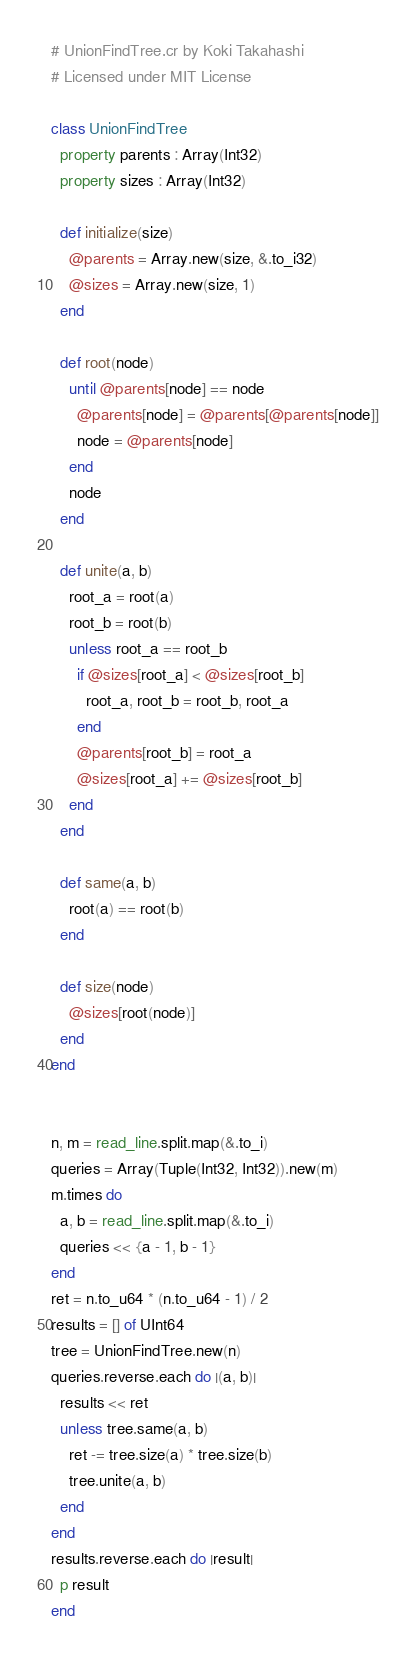Convert code to text. <code><loc_0><loc_0><loc_500><loc_500><_Crystal_># UnionFindTree.cr by Koki Takahashi
# Licensed under MIT License

class UnionFindTree
  property parents : Array(Int32)
  property sizes : Array(Int32)

  def initialize(size)
    @parents = Array.new(size, &.to_i32)
    @sizes = Array.new(size, 1)
  end

  def root(node)
    until @parents[node] == node
      @parents[node] = @parents[@parents[node]]
      node = @parents[node]
    end
    node
  end

  def unite(a, b)
    root_a = root(a)
    root_b = root(b)
    unless root_a == root_b
      if @sizes[root_a] < @sizes[root_b]
        root_a, root_b = root_b, root_a
      end
      @parents[root_b] = root_a
      @sizes[root_a] += @sizes[root_b]
    end
  end

  def same(a, b)
    root(a) == root(b)
  end

  def size(node)
    @sizes[root(node)]
  end
end


n, m = read_line.split.map(&.to_i)
queries = Array(Tuple(Int32, Int32)).new(m)
m.times do
  a, b = read_line.split.map(&.to_i)
  queries << {a - 1, b - 1}
end
ret = n.to_u64 * (n.to_u64 - 1) / 2
results = [] of UInt64
tree = UnionFindTree.new(n)
queries.reverse.each do |(a, b)|
  results << ret
  unless tree.same(a, b)
    ret -= tree.size(a) * tree.size(b)
    tree.unite(a, b)
  end
end
results.reverse.each do |result|
  p result
end</code> 